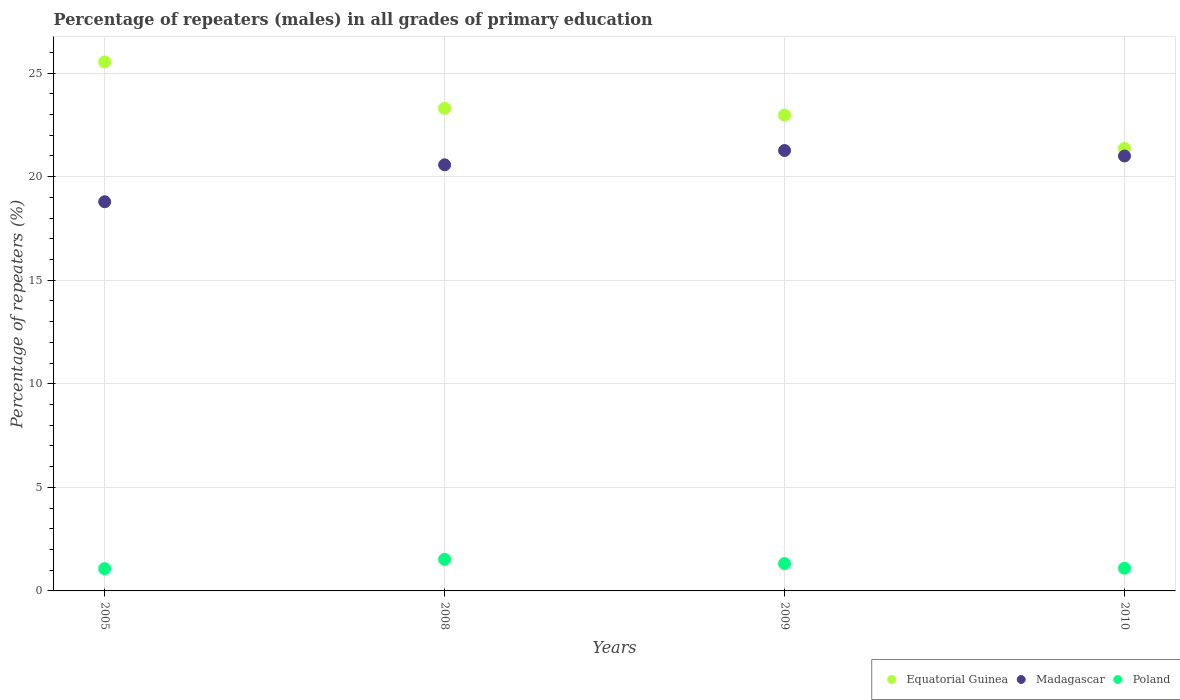Is the number of dotlines equal to the number of legend labels?
Offer a very short reply. Yes. What is the percentage of repeaters (males) in Poland in 2009?
Keep it short and to the point. 1.32. Across all years, what is the maximum percentage of repeaters (males) in Equatorial Guinea?
Offer a terse response. 25.54. Across all years, what is the minimum percentage of repeaters (males) in Poland?
Provide a short and direct response. 1.07. In which year was the percentage of repeaters (males) in Madagascar maximum?
Your answer should be very brief. 2009. In which year was the percentage of repeaters (males) in Poland minimum?
Offer a terse response. 2005. What is the total percentage of repeaters (males) in Equatorial Guinea in the graph?
Your answer should be very brief. 93.17. What is the difference between the percentage of repeaters (males) in Poland in 2008 and that in 2009?
Give a very brief answer. 0.2. What is the difference between the percentage of repeaters (males) in Madagascar in 2005 and the percentage of repeaters (males) in Equatorial Guinea in 2010?
Give a very brief answer. -2.57. What is the average percentage of repeaters (males) in Madagascar per year?
Provide a short and direct response. 20.41. In the year 2008, what is the difference between the percentage of repeaters (males) in Poland and percentage of repeaters (males) in Madagascar?
Keep it short and to the point. -19.05. In how many years, is the percentage of repeaters (males) in Poland greater than 11 %?
Your response must be concise. 0. What is the ratio of the percentage of repeaters (males) in Madagascar in 2005 to that in 2009?
Provide a succinct answer. 0.88. Is the difference between the percentage of repeaters (males) in Poland in 2005 and 2008 greater than the difference between the percentage of repeaters (males) in Madagascar in 2005 and 2008?
Make the answer very short. Yes. What is the difference between the highest and the second highest percentage of repeaters (males) in Poland?
Keep it short and to the point. 0.2. What is the difference between the highest and the lowest percentage of repeaters (males) in Equatorial Guinea?
Your answer should be compact. 4.18. Is the sum of the percentage of repeaters (males) in Poland in 2005 and 2008 greater than the maximum percentage of repeaters (males) in Madagascar across all years?
Provide a succinct answer. No. Is it the case that in every year, the sum of the percentage of repeaters (males) in Poland and percentage of repeaters (males) in Equatorial Guinea  is greater than the percentage of repeaters (males) in Madagascar?
Ensure brevity in your answer.  Yes. Does the percentage of repeaters (males) in Equatorial Guinea monotonically increase over the years?
Keep it short and to the point. No. Is the percentage of repeaters (males) in Madagascar strictly greater than the percentage of repeaters (males) in Equatorial Guinea over the years?
Ensure brevity in your answer.  No. What is the difference between two consecutive major ticks on the Y-axis?
Your answer should be compact. 5. Are the values on the major ticks of Y-axis written in scientific E-notation?
Offer a very short reply. No. What is the title of the graph?
Keep it short and to the point. Percentage of repeaters (males) in all grades of primary education. What is the label or title of the X-axis?
Make the answer very short. Years. What is the label or title of the Y-axis?
Offer a terse response. Percentage of repeaters (%). What is the Percentage of repeaters (%) in Equatorial Guinea in 2005?
Offer a terse response. 25.54. What is the Percentage of repeaters (%) of Madagascar in 2005?
Your answer should be compact. 18.79. What is the Percentage of repeaters (%) in Poland in 2005?
Make the answer very short. 1.07. What is the Percentage of repeaters (%) in Equatorial Guinea in 2008?
Give a very brief answer. 23.3. What is the Percentage of repeaters (%) in Madagascar in 2008?
Offer a very short reply. 20.57. What is the Percentage of repeaters (%) of Poland in 2008?
Your answer should be compact. 1.52. What is the Percentage of repeaters (%) of Equatorial Guinea in 2009?
Your answer should be compact. 22.97. What is the Percentage of repeaters (%) in Madagascar in 2009?
Offer a very short reply. 21.26. What is the Percentage of repeaters (%) in Poland in 2009?
Your answer should be compact. 1.32. What is the Percentage of repeaters (%) of Equatorial Guinea in 2010?
Ensure brevity in your answer.  21.36. What is the Percentage of repeaters (%) in Madagascar in 2010?
Keep it short and to the point. 21. What is the Percentage of repeaters (%) in Poland in 2010?
Your answer should be compact. 1.1. Across all years, what is the maximum Percentage of repeaters (%) of Equatorial Guinea?
Your response must be concise. 25.54. Across all years, what is the maximum Percentage of repeaters (%) in Madagascar?
Ensure brevity in your answer.  21.26. Across all years, what is the maximum Percentage of repeaters (%) of Poland?
Ensure brevity in your answer.  1.52. Across all years, what is the minimum Percentage of repeaters (%) of Equatorial Guinea?
Keep it short and to the point. 21.36. Across all years, what is the minimum Percentage of repeaters (%) of Madagascar?
Offer a very short reply. 18.79. Across all years, what is the minimum Percentage of repeaters (%) in Poland?
Ensure brevity in your answer.  1.07. What is the total Percentage of repeaters (%) in Equatorial Guinea in the graph?
Keep it short and to the point. 93.17. What is the total Percentage of repeaters (%) in Madagascar in the graph?
Provide a succinct answer. 81.62. What is the total Percentage of repeaters (%) in Poland in the graph?
Make the answer very short. 5.01. What is the difference between the Percentage of repeaters (%) in Equatorial Guinea in 2005 and that in 2008?
Give a very brief answer. 2.24. What is the difference between the Percentage of repeaters (%) of Madagascar in 2005 and that in 2008?
Provide a short and direct response. -1.78. What is the difference between the Percentage of repeaters (%) in Poland in 2005 and that in 2008?
Offer a terse response. -0.45. What is the difference between the Percentage of repeaters (%) of Equatorial Guinea in 2005 and that in 2009?
Your response must be concise. 2.57. What is the difference between the Percentage of repeaters (%) in Madagascar in 2005 and that in 2009?
Offer a terse response. -2.47. What is the difference between the Percentage of repeaters (%) in Poland in 2005 and that in 2009?
Your response must be concise. -0.24. What is the difference between the Percentage of repeaters (%) in Equatorial Guinea in 2005 and that in 2010?
Give a very brief answer. 4.18. What is the difference between the Percentage of repeaters (%) in Madagascar in 2005 and that in 2010?
Your answer should be compact. -2.21. What is the difference between the Percentage of repeaters (%) of Poland in 2005 and that in 2010?
Offer a terse response. -0.02. What is the difference between the Percentage of repeaters (%) of Equatorial Guinea in 2008 and that in 2009?
Your answer should be very brief. 0.33. What is the difference between the Percentage of repeaters (%) in Madagascar in 2008 and that in 2009?
Give a very brief answer. -0.69. What is the difference between the Percentage of repeaters (%) in Poland in 2008 and that in 2009?
Make the answer very short. 0.2. What is the difference between the Percentage of repeaters (%) of Equatorial Guinea in 2008 and that in 2010?
Ensure brevity in your answer.  1.94. What is the difference between the Percentage of repeaters (%) of Madagascar in 2008 and that in 2010?
Your answer should be very brief. -0.43. What is the difference between the Percentage of repeaters (%) of Poland in 2008 and that in 2010?
Your answer should be compact. 0.43. What is the difference between the Percentage of repeaters (%) of Equatorial Guinea in 2009 and that in 2010?
Ensure brevity in your answer.  1.61. What is the difference between the Percentage of repeaters (%) in Madagascar in 2009 and that in 2010?
Your response must be concise. 0.27. What is the difference between the Percentage of repeaters (%) in Poland in 2009 and that in 2010?
Your answer should be compact. 0.22. What is the difference between the Percentage of repeaters (%) of Equatorial Guinea in 2005 and the Percentage of repeaters (%) of Madagascar in 2008?
Give a very brief answer. 4.97. What is the difference between the Percentage of repeaters (%) of Equatorial Guinea in 2005 and the Percentage of repeaters (%) of Poland in 2008?
Provide a succinct answer. 24.02. What is the difference between the Percentage of repeaters (%) of Madagascar in 2005 and the Percentage of repeaters (%) of Poland in 2008?
Keep it short and to the point. 17.27. What is the difference between the Percentage of repeaters (%) of Equatorial Guinea in 2005 and the Percentage of repeaters (%) of Madagascar in 2009?
Offer a very short reply. 4.28. What is the difference between the Percentage of repeaters (%) in Equatorial Guinea in 2005 and the Percentage of repeaters (%) in Poland in 2009?
Provide a succinct answer. 24.22. What is the difference between the Percentage of repeaters (%) of Madagascar in 2005 and the Percentage of repeaters (%) of Poland in 2009?
Ensure brevity in your answer.  17.47. What is the difference between the Percentage of repeaters (%) of Equatorial Guinea in 2005 and the Percentage of repeaters (%) of Madagascar in 2010?
Your answer should be very brief. 4.54. What is the difference between the Percentage of repeaters (%) in Equatorial Guinea in 2005 and the Percentage of repeaters (%) in Poland in 2010?
Give a very brief answer. 24.44. What is the difference between the Percentage of repeaters (%) of Madagascar in 2005 and the Percentage of repeaters (%) of Poland in 2010?
Provide a short and direct response. 17.69. What is the difference between the Percentage of repeaters (%) in Equatorial Guinea in 2008 and the Percentage of repeaters (%) in Madagascar in 2009?
Keep it short and to the point. 2.04. What is the difference between the Percentage of repeaters (%) of Equatorial Guinea in 2008 and the Percentage of repeaters (%) of Poland in 2009?
Keep it short and to the point. 21.98. What is the difference between the Percentage of repeaters (%) in Madagascar in 2008 and the Percentage of repeaters (%) in Poland in 2009?
Provide a short and direct response. 19.25. What is the difference between the Percentage of repeaters (%) of Equatorial Guinea in 2008 and the Percentage of repeaters (%) of Madagascar in 2010?
Offer a terse response. 2.3. What is the difference between the Percentage of repeaters (%) of Equatorial Guinea in 2008 and the Percentage of repeaters (%) of Poland in 2010?
Offer a very short reply. 22.2. What is the difference between the Percentage of repeaters (%) in Madagascar in 2008 and the Percentage of repeaters (%) in Poland in 2010?
Ensure brevity in your answer.  19.48. What is the difference between the Percentage of repeaters (%) in Equatorial Guinea in 2009 and the Percentage of repeaters (%) in Madagascar in 2010?
Ensure brevity in your answer.  1.98. What is the difference between the Percentage of repeaters (%) of Equatorial Guinea in 2009 and the Percentage of repeaters (%) of Poland in 2010?
Ensure brevity in your answer.  21.88. What is the difference between the Percentage of repeaters (%) of Madagascar in 2009 and the Percentage of repeaters (%) of Poland in 2010?
Offer a very short reply. 20.17. What is the average Percentage of repeaters (%) in Equatorial Guinea per year?
Your response must be concise. 23.29. What is the average Percentage of repeaters (%) in Madagascar per year?
Your response must be concise. 20.41. What is the average Percentage of repeaters (%) in Poland per year?
Keep it short and to the point. 1.25. In the year 2005, what is the difference between the Percentage of repeaters (%) of Equatorial Guinea and Percentage of repeaters (%) of Madagascar?
Provide a short and direct response. 6.75. In the year 2005, what is the difference between the Percentage of repeaters (%) in Equatorial Guinea and Percentage of repeaters (%) in Poland?
Ensure brevity in your answer.  24.47. In the year 2005, what is the difference between the Percentage of repeaters (%) in Madagascar and Percentage of repeaters (%) in Poland?
Your response must be concise. 17.71. In the year 2008, what is the difference between the Percentage of repeaters (%) in Equatorial Guinea and Percentage of repeaters (%) in Madagascar?
Give a very brief answer. 2.73. In the year 2008, what is the difference between the Percentage of repeaters (%) in Equatorial Guinea and Percentage of repeaters (%) in Poland?
Offer a terse response. 21.78. In the year 2008, what is the difference between the Percentage of repeaters (%) in Madagascar and Percentage of repeaters (%) in Poland?
Keep it short and to the point. 19.05. In the year 2009, what is the difference between the Percentage of repeaters (%) in Equatorial Guinea and Percentage of repeaters (%) in Madagascar?
Make the answer very short. 1.71. In the year 2009, what is the difference between the Percentage of repeaters (%) in Equatorial Guinea and Percentage of repeaters (%) in Poland?
Offer a very short reply. 21.65. In the year 2009, what is the difference between the Percentage of repeaters (%) of Madagascar and Percentage of repeaters (%) of Poland?
Your answer should be very brief. 19.94. In the year 2010, what is the difference between the Percentage of repeaters (%) in Equatorial Guinea and Percentage of repeaters (%) in Madagascar?
Provide a short and direct response. 0.36. In the year 2010, what is the difference between the Percentage of repeaters (%) of Equatorial Guinea and Percentage of repeaters (%) of Poland?
Provide a short and direct response. 20.27. In the year 2010, what is the difference between the Percentage of repeaters (%) in Madagascar and Percentage of repeaters (%) in Poland?
Provide a short and direct response. 19.9. What is the ratio of the Percentage of repeaters (%) in Equatorial Guinea in 2005 to that in 2008?
Keep it short and to the point. 1.1. What is the ratio of the Percentage of repeaters (%) of Madagascar in 2005 to that in 2008?
Offer a very short reply. 0.91. What is the ratio of the Percentage of repeaters (%) in Poland in 2005 to that in 2008?
Offer a very short reply. 0.71. What is the ratio of the Percentage of repeaters (%) of Equatorial Guinea in 2005 to that in 2009?
Give a very brief answer. 1.11. What is the ratio of the Percentage of repeaters (%) in Madagascar in 2005 to that in 2009?
Ensure brevity in your answer.  0.88. What is the ratio of the Percentage of repeaters (%) of Poland in 2005 to that in 2009?
Keep it short and to the point. 0.82. What is the ratio of the Percentage of repeaters (%) of Equatorial Guinea in 2005 to that in 2010?
Give a very brief answer. 1.2. What is the ratio of the Percentage of repeaters (%) of Madagascar in 2005 to that in 2010?
Ensure brevity in your answer.  0.89. What is the ratio of the Percentage of repeaters (%) in Poland in 2005 to that in 2010?
Provide a succinct answer. 0.98. What is the ratio of the Percentage of repeaters (%) of Equatorial Guinea in 2008 to that in 2009?
Give a very brief answer. 1.01. What is the ratio of the Percentage of repeaters (%) of Madagascar in 2008 to that in 2009?
Your answer should be compact. 0.97. What is the ratio of the Percentage of repeaters (%) in Poland in 2008 to that in 2009?
Keep it short and to the point. 1.16. What is the ratio of the Percentage of repeaters (%) in Equatorial Guinea in 2008 to that in 2010?
Keep it short and to the point. 1.09. What is the ratio of the Percentage of repeaters (%) in Madagascar in 2008 to that in 2010?
Keep it short and to the point. 0.98. What is the ratio of the Percentage of repeaters (%) of Poland in 2008 to that in 2010?
Offer a terse response. 1.39. What is the ratio of the Percentage of repeaters (%) in Equatorial Guinea in 2009 to that in 2010?
Keep it short and to the point. 1.08. What is the ratio of the Percentage of repeaters (%) of Madagascar in 2009 to that in 2010?
Provide a short and direct response. 1.01. What is the ratio of the Percentage of repeaters (%) in Poland in 2009 to that in 2010?
Your response must be concise. 1.2. What is the difference between the highest and the second highest Percentage of repeaters (%) of Equatorial Guinea?
Offer a very short reply. 2.24. What is the difference between the highest and the second highest Percentage of repeaters (%) of Madagascar?
Ensure brevity in your answer.  0.27. What is the difference between the highest and the second highest Percentage of repeaters (%) of Poland?
Offer a terse response. 0.2. What is the difference between the highest and the lowest Percentage of repeaters (%) of Equatorial Guinea?
Your answer should be very brief. 4.18. What is the difference between the highest and the lowest Percentage of repeaters (%) in Madagascar?
Keep it short and to the point. 2.47. What is the difference between the highest and the lowest Percentage of repeaters (%) in Poland?
Your response must be concise. 0.45. 